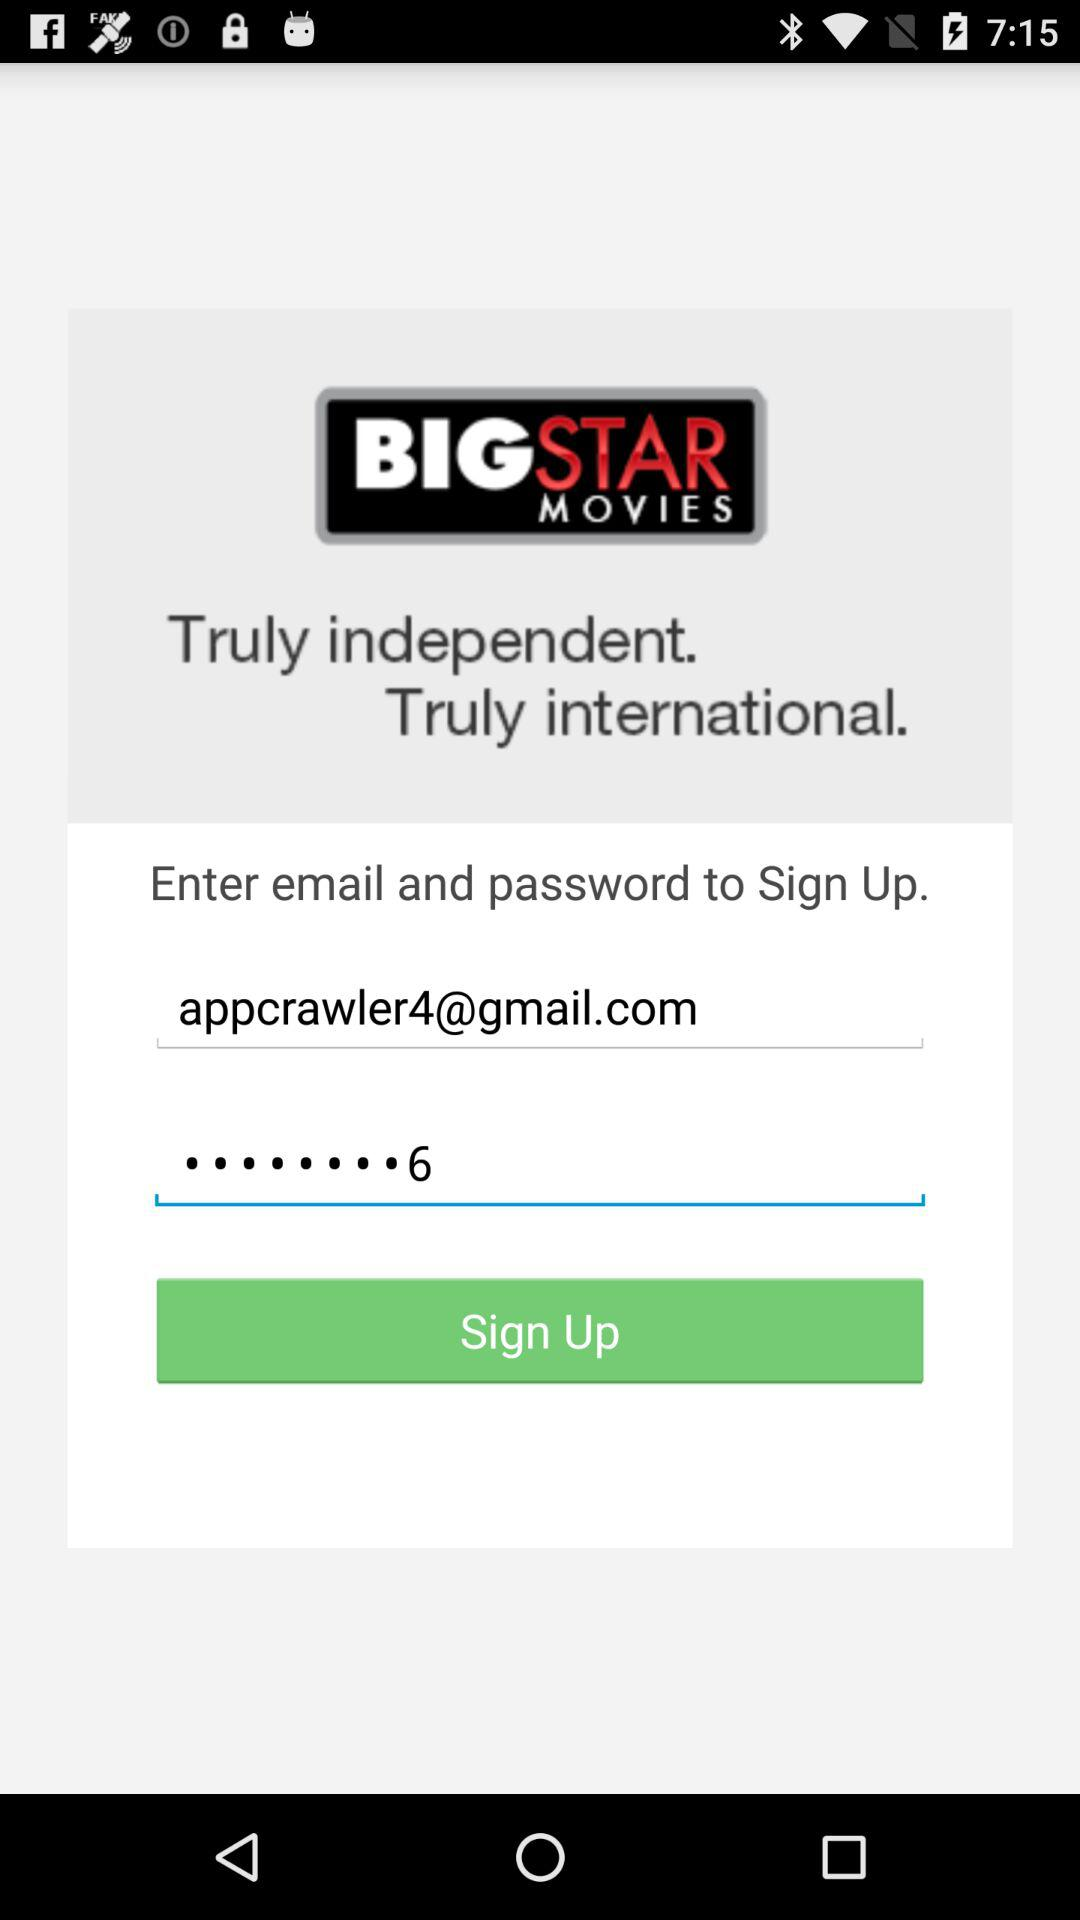What is the email address? The email address is appcrawler4@gmail.com. 